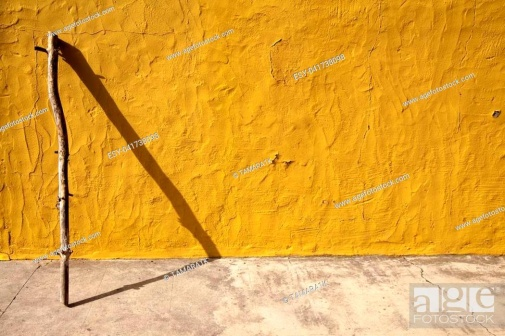Create a dialogue between the wall and the stick. Stick: 'Ah, to lean and rest, what a joy after so many travels.'
Wall: 'Indeed, you've seen much beyond this village. What tales could you share?'
Stick: 'Mountains, forests, cities bustling with life - I've seen them all. And you, standing tall here, witnessing the days go by?'
Wall: 'I've seen generations grow, seasons change, stories unfold. You're but a fleeting visitor, yet together, we shape this moment's story.'
Stick: 'Then let us savor it, for in our stillness lies a world unseen.' 